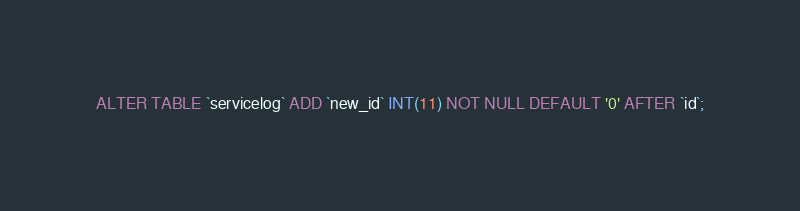<code> <loc_0><loc_0><loc_500><loc_500><_SQL_>ALTER TABLE `servicelog` ADD `new_id` INT(11) NOT NULL DEFAULT '0' AFTER `id`;</code> 